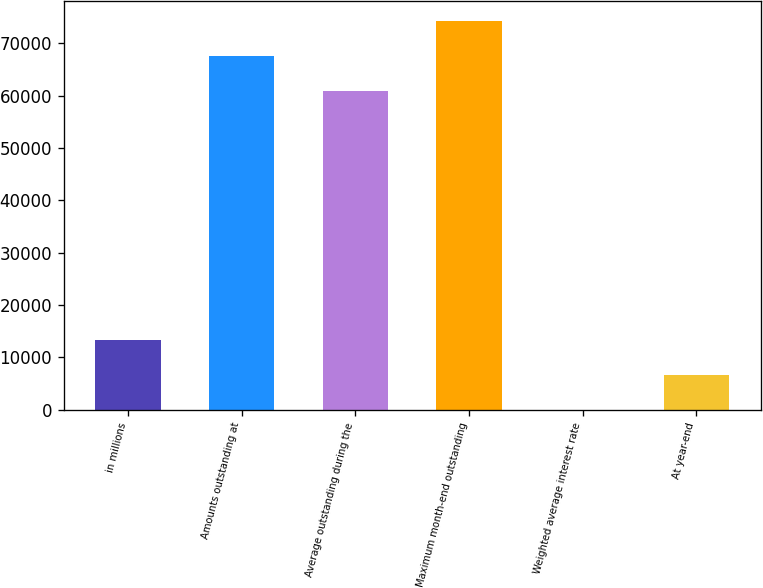Convert chart. <chart><loc_0><loc_0><loc_500><loc_500><bar_chart><fcel>in millions<fcel>Amounts outstanding at<fcel>Average outstanding during the<fcel>Maximum month-end outstanding<fcel>Weighted average interest rate<fcel>At year-end<nl><fcel>13396.1<fcel>67623.7<fcel>60926<fcel>74321.5<fcel>0.65<fcel>6698.39<nl></chart> 